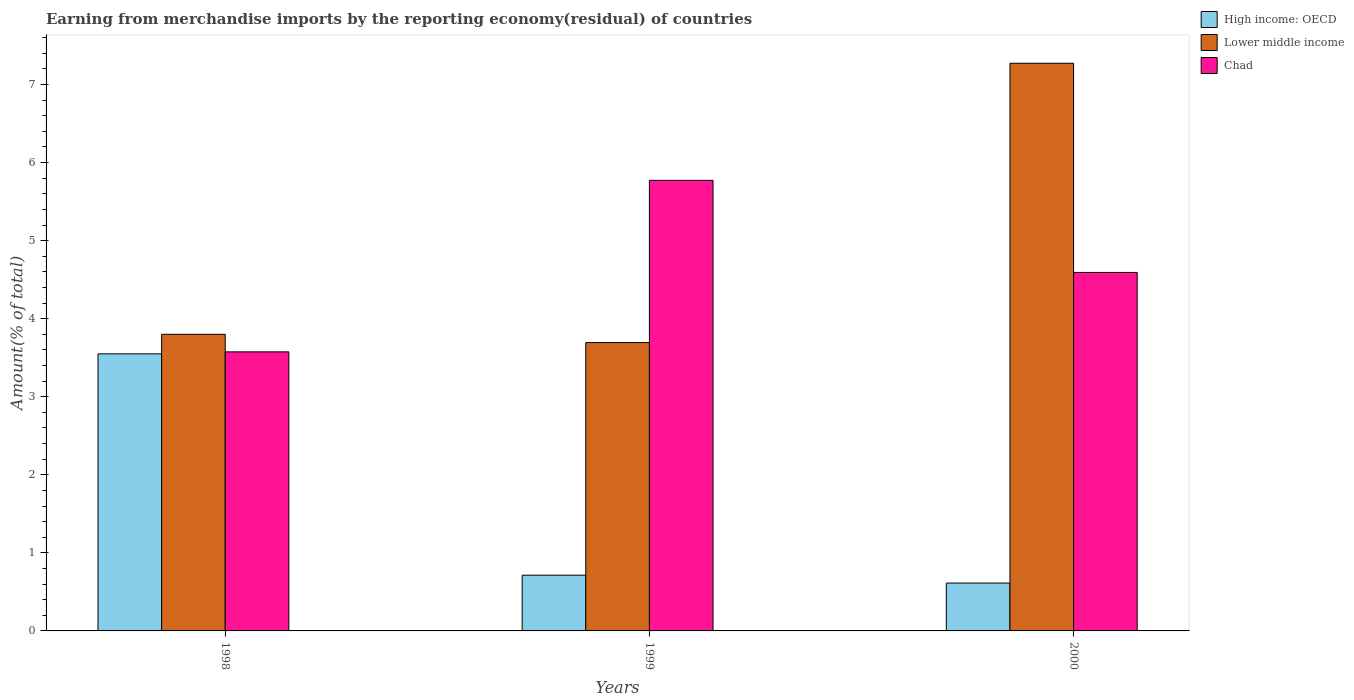How many different coloured bars are there?
Keep it short and to the point. 3. How many groups of bars are there?
Ensure brevity in your answer.  3. How many bars are there on the 1st tick from the right?
Make the answer very short. 3. In how many cases, is the number of bars for a given year not equal to the number of legend labels?
Make the answer very short. 0. What is the percentage of amount earned from merchandise imports in High income: OECD in 1999?
Keep it short and to the point. 0.71. Across all years, what is the maximum percentage of amount earned from merchandise imports in Lower middle income?
Give a very brief answer. 7.27. Across all years, what is the minimum percentage of amount earned from merchandise imports in Lower middle income?
Give a very brief answer. 3.69. What is the total percentage of amount earned from merchandise imports in Lower middle income in the graph?
Provide a succinct answer. 14.77. What is the difference between the percentage of amount earned from merchandise imports in Lower middle income in 1998 and that in 2000?
Make the answer very short. -3.47. What is the difference between the percentage of amount earned from merchandise imports in Lower middle income in 2000 and the percentage of amount earned from merchandise imports in High income: OECD in 1999?
Offer a very short reply. 6.56. What is the average percentage of amount earned from merchandise imports in High income: OECD per year?
Your answer should be very brief. 1.63. In the year 2000, what is the difference between the percentage of amount earned from merchandise imports in Lower middle income and percentage of amount earned from merchandise imports in Chad?
Your answer should be very brief. 2.68. In how many years, is the percentage of amount earned from merchandise imports in Lower middle income greater than 3.8 %?
Give a very brief answer. 1. What is the ratio of the percentage of amount earned from merchandise imports in Lower middle income in 1998 to that in 2000?
Keep it short and to the point. 0.52. Is the percentage of amount earned from merchandise imports in Chad in 1998 less than that in 2000?
Keep it short and to the point. Yes. Is the difference between the percentage of amount earned from merchandise imports in Lower middle income in 1999 and 2000 greater than the difference between the percentage of amount earned from merchandise imports in Chad in 1999 and 2000?
Offer a very short reply. No. What is the difference between the highest and the second highest percentage of amount earned from merchandise imports in Lower middle income?
Your response must be concise. 3.47. What is the difference between the highest and the lowest percentage of amount earned from merchandise imports in Chad?
Your response must be concise. 2.2. What does the 2nd bar from the left in 2000 represents?
Your answer should be compact. Lower middle income. What does the 1st bar from the right in 1999 represents?
Your answer should be compact. Chad. How many bars are there?
Your response must be concise. 9. Does the graph contain grids?
Your answer should be compact. No. How many legend labels are there?
Make the answer very short. 3. What is the title of the graph?
Your answer should be compact. Earning from merchandise imports by the reporting economy(residual) of countries. Does "Dominica" appear as one of the legend labels in the graph?
Your answer should be very brief. No. What is the label or title of the Y-axis?
Provide a short and direct response. Amount(% of total). What is the Amount(% of total) of High income: OECD in 1998?
Give a very brief answer. 3.55. What is the Amount(% of total) of Lower middle income in 1998?
Give a very brief answer. 3.8. What is the Amount(% of total) of Chad in 1998?
Ensure brevity in your answer.  3.57. What is the Amount(% of total) of High income: OECD in 1999?
Make the answer very short. 0.71. What is the Amount(% of total) of Lower middle income in 1999?
Your answer should be compact. 3.69. What is the Amount(% of total) of Chad in 1999?
Offer a very short reply. 5.77. What is the Amount(% of total) in High income: OECD in 2000?
Make the answer very short. 0.61. What is the Amount(% of total) in Lower middle income in 2000?
Provide a succinct answer. 7.27. What is the Amount(% of total) of Chad in 2000?
Your answer should be compact. 4.59. Across all years, what is the maximum Amount(% of total) in High income: OECD?
Give a very brief answer. 3.55. Across all years, what is the maximum Amount(% of total) in Lower middle income?
Make the answer very short. 7.27. Across all years, what is the maximum Amount(% of total) of Chad?
Your answer should be very brief. 5.77. Across all years, what is the minimum Amount(% of total) of High income: OECD?
Your answer should be very brief. 0.61. Across all years, what is the minimum Amount(% of total) of Lower middle income?
Offer a terse response. 3.69. Across all years, what is the minimum Amount(% of total) in Chad?
Your answer should be compact. 3.57. What is the total Amount(% of total) in High income: OECD in the graph?
Offer a very short reply. 4.88. What is the total Amount(% of total) in Lower middle income in the graph?
Keep it short and to the point. 14.77. What is the total Amount(% of total) of Chad in the graph?
Your response must be concise. 13.94. What is the difference between the Amount(% of total) of High income: OECD in 1998 and that in 1999?
Offer a very short reply. 2.84. What is the difference between the Amount(% of total) in Lower middle income in 1998 and that in 1999?
Your answer should be compact. 0.11. What is the difference between the Amount(% of total) in Chad in 1998 and that in 1999?
Offer a very short reply. -2.2. What is the difference between the Amount(% of total) of High income: OECD in 1998 and that in 2000?
Offer a very short reply. 2.94. What is the difference between the Amount(% of total) of Lower middle income in 1998 and that in 2000?
Offer a very short reply. -3.47. What is the difference between the Amount(% of total) of Chad in 1998 and that in 2000?
Offer a very short reply. -1.02. What is the difference between the Amount(% of total) in High income: OECD in 1999 and that in 2000?
Provide a short and direct response. 0.1. What is the difference between the Amount(% of total) in Lower middle income in 1999 and that in 2000?
Offer a very short reply. -3.58. What is the difference between the Amount(% of total) of Chad in 1999 and that in 2000?
Your answer should be compact. 1.18. What is the difference between the Amount(% of total) in High income: OECD in 1998 and the Amount(% of total) in Lower middle income in 1999?
Your response must be concise. -0.14. What is the difference between the Amount(% of total) in High income: OECD in 1998 and the Amount(% of total) in Chad in 1999?
Provide a short and direct response. -2.22. What is the difference between the Amount(% of total) in Lower middle income in 1998 and the Amount(% of total) in Chad in 1999?
Provide a succinct answer. -1.97. What is the difference between the Amount(% of total) in High income: OECD in 1998 and the Amount(% of total) in Lower middle income in 2000?
Offer a terse response. -3.72. What is the difference between the Amount(% of total) of High income: OECD in 1998 and the Amount(% of total) of Chad in 2000?
Your answer should be very brief. -1.04. What is the difference between the Amount(% of total) in Lower middle income in 1998 and the Amount(% of total) in Chad in 2000?
Ensure brevity in your answer.  -0.79. What is the difference between the Amount(% of total) of High income: OECD in 1999 and the Amount(% of total) of Lower middle income in 2000?
Ensure brevity in your answer.  -6.56. What is the difference between the Amount(% of total) of High income: OECD in 1999 and the Amount(% of total) of Chad in 2000?
Offer a terse response. -3.88. What is the difference between the Amount(% of total) in Lower middle income in 1999 and the Amount(% of total) in Chad in 2000?
Provide a short and direct response. -0.9. What is the average Amount(% of total) in High income: OECD per year?
Offer a terse response. 1.63. What is the average Amount(% of total) in Lower middle income per year?
Offer a terse response. 4.92. What is the average Amount(% of total) in Chad per year?
Offer a terse response. 4.65. In the year 1998, what is the difference between the Amount(% of total) in High income: OECD and Amount(% of total) in Lower middle income?
Ensure brevity in your answer.  -0.25. In the year 1998, what is the difference between the Amount(% of total) of High income: OECD and Amount(% of total) of Chad?
Provide a succinct answer. -0.03. In the year 1998, what is the difference between the Amount(% of total) in Lower middle income and Amount(% of total) in Chad?
Make the answer very short. 0.23. In the year 1999, what is the difference between the Amount(% of total) in High income: OECD and Amount(% of total) in Lower middle income?
Keep it short and to the point. -2.98. In the year 1999, what is the difference between the Amount(% of total) of High income: OECD and Amount(% of total) of Chad?
Provide a short and direct response. -5.06. In the year 1999, what is the difference between the Amount(% of total) of Lower middle income and Amount(% of total) of Chad?
Make the answer very short. -2.08. In the year 2000, what is the difference between the Amount(% of total) in High income: OECD and Amount(% of total) in Lower middle income?
Offer a very short reply. -6.66. In the year 2000, what is the difference between the Amount(% of total) in High income: OECD and Amount(% of total) in Chad?
Ensure brevity in your answer.  -3.98. In the year 2000, what is the difference between the Amount(% of total) of Lower middle income and Amount(% of total) of Chad?
Your response must be concise. 2.68. What is the ratio of the Amount(% of total) of High income: OECD in 1998 to that in 1999?
Give a very brief answer. 4.97. What is the ratio of the Amount(% of total) of Lower middle income in 1998 to that in 1999?
Give a very brief answer. 1.03. What is the ratio of the Amount(% of total) of Chad in 1998 to that in 1999?
Ensure brevity in your answer.  0.62. What is the ratio of the Amount(% of total) of High income: OECD in 1998 to that in 2000?
Your answer should be very brief. 5.79. What is the ratio of the Amount(% of total) in Lower middle income in 1998 to that in 2000?
Provide a short and direct response. 0.52. What is the ratio of the Amount(% of total) in Chad in 1998 to that in 2000?
Make the answer very short. 0.78. What is the ratio of the Amount(% of total) in High income: OECD in 1999 to that in 2000?
Your response must be concise. 1.16. What is the ratio of the Amount(% of total) of Lower middle income in 1999 to that in 2000?
Offer a terse response. 0.51. What is the ratio of the Amount(% of total) in Chad in 1999 to that in 2000?
Offer a terse response. 1.26. What is the difference between the highest and the second highest Amount(% of total) of High income: OECD?
Offer a very short reply. 2.84. What is the difference between the highest and the second highest Amount(% of total) of Lower middle income?
Provide a succinct answer. 3.47. What is the difference between the highest and the second highest Amount(% of total) of Chad?
Give a very brief answer. 1.18. What is the difference between the highest and the lowest Amount(% of total) in High income: OECD?
Keep it short and to the point. 2.94. What is the difference between the highest and the lowest Amount(% of total) in Lower middle income?
Offer a very short reply. 3.58. What is the difference between the highest and the lowest Amount(% of total) of Chad?
Your response must be concise. 2.2. 